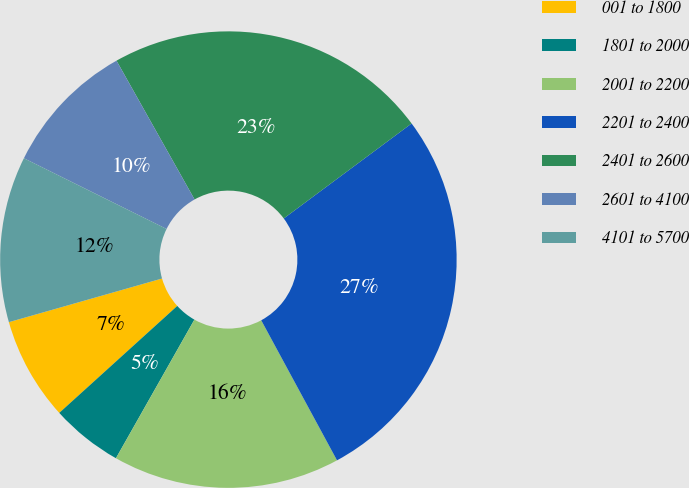Convert chart to OTSL. <chart><loc_0><loc_0><loc_500><loc_500><pie_chart><fcel>001 to 1800<fcel>1801 to 2000<fcel>2001 to 2200<fcel>2201 to 2400<fcel>2401 to 2600<fcel>2601 to 4100<fcel>4101 to 5700<nl><fcel>7.3%<fcel>5.08%<fcel>16.09%<fcel>27.27%<fcel>22.98%<fcel>9.52%<fcel>11.74%<nl></chart> 